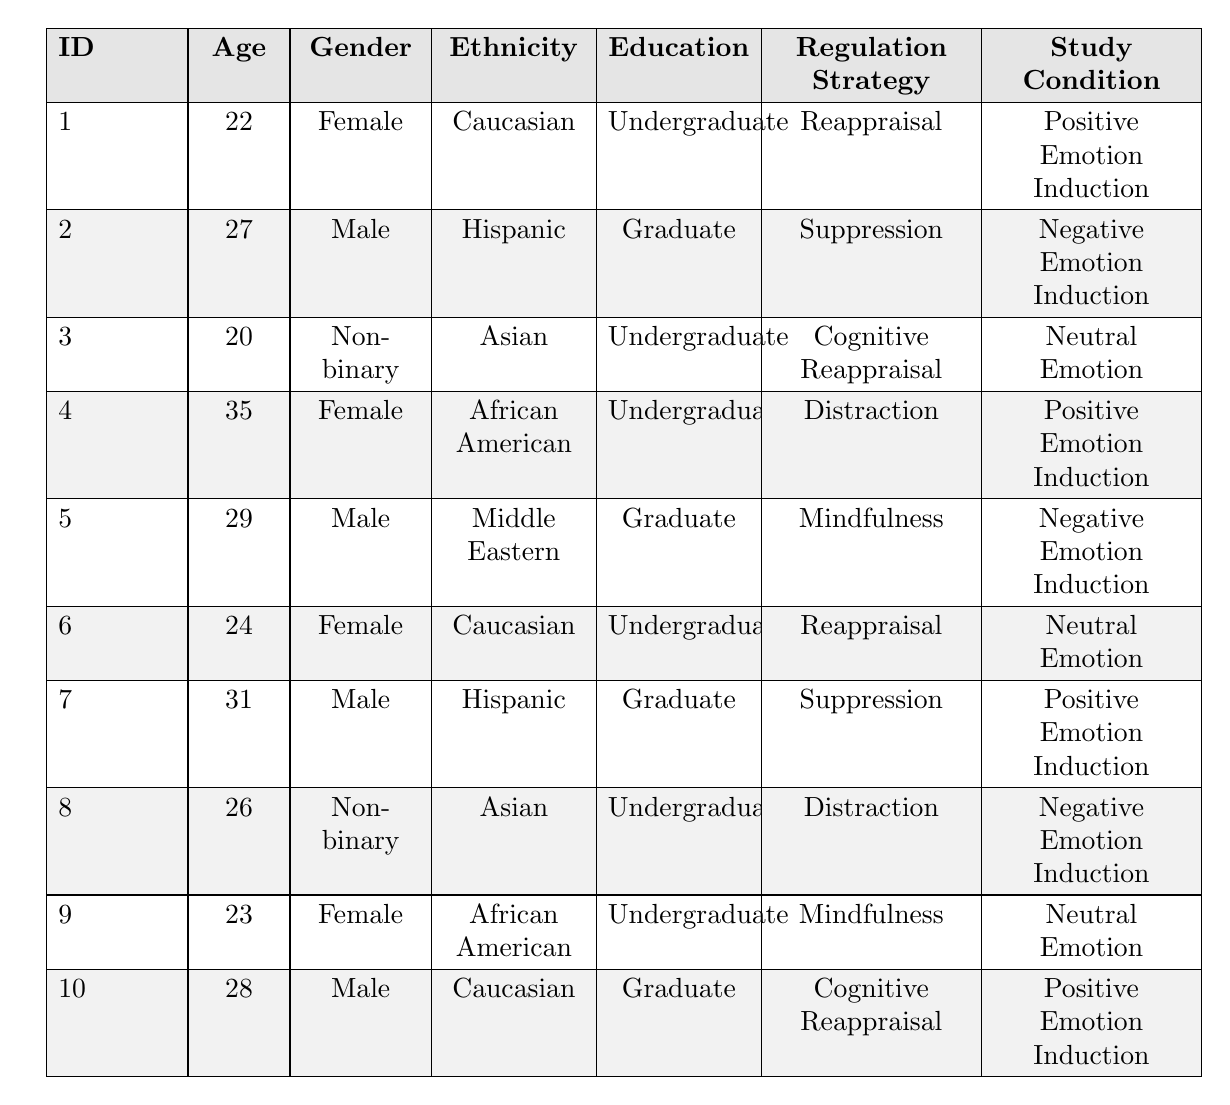What is the age of participant 1? The age of participant 1 is listed in the table as 22.
Answer: 22 How many male participants are there? Counting the table, there are 4 male participants (participant id 2, 5, 7, and 10).
Answer: 4 What emotion regulation strategy is used by participant 6? The table shows that participant 6 uses the reappraisal strategy.
Answer: Reappraisal What is the education level of participant 4? The table indicates that participant 4 has an undergraduate education level.
Answer: Undergraduate Which participant has the highest age? Scanning through the ages, participant 4 is the oldest at 35 years.
Answer: 35 Are there any participants who employ the mindfulness strategy? Yes, there are two participants (id 5 and 9) using mindfulness as their strategy.
Answer: Yes What is the average age of participants using the positive emotion induction condition? The ages for the positive emotion induction condition are 22 (id 1), 35 (id 4), 31 (id 7), and 28 (id 10). The sum is 22 + 35 + 31 + 28 = 116 and the average is 116/4 = 29.
Answer: 29 Which study condition has the highest representation in the table? There are 4 participants in the positive emotion induction condition, 3 in the negative emotion induction condition, and 3 in the neutral emotion condition. Since 4 > 3, positive emotion induction has the highest representation.
Answer: Positive Emotion Induction What proportion of participants are non-binary? There are 3 non-binary participants (id 3 and 8) out of a total of 10 participants. To find the proportion, 3/10 = 0.3.
Answer: 0.3 Is there a participant who uses the distraction strategy and is of Hispanic ethnicity? No, there is no participant who matches this criterion as participant id 7 who is Hispanic uses suppression, and participant id 8 who uses distraction is Asian.
Answer: No How many participants have a graduate education level? The table shows that there are 4 participants with a graduate education level (id 2, 5, 7, 10).
Answer: 4 